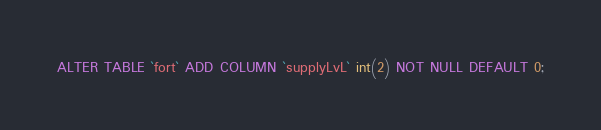<code> <loc_0><loc_0><loc_500><loc_500><_SQL_>ALTER TABLE `fort` ADD COLUMN `supplyLvL` int(2) NOT NULL DEFAULT 0;</code> 